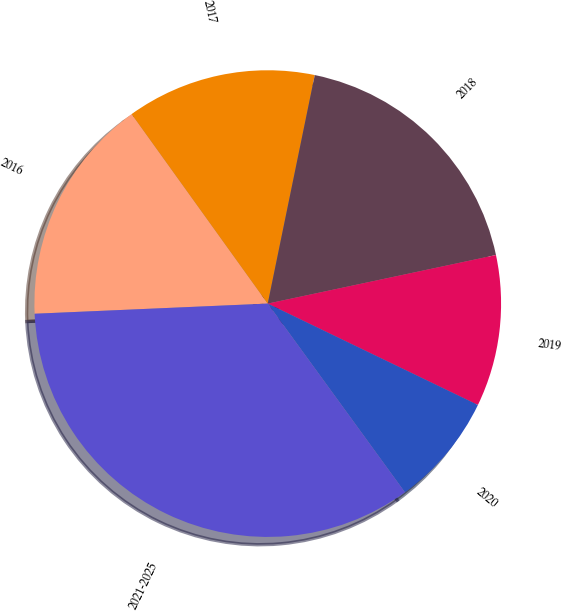Convert chart to OTSL. <chart><loc_0><loc_0><loc_500><loc_500><pie_chart><fcel>2016<fcel>2017<fcel>2018<fcel>2019<fcel>2020<fcel>2021-2025<nl><fcel>15.78%<fcel>13.14%<fcel>18.43%<fcel>10.49%<fcel>7.84%<fcel>34.31%<nl></chart> 